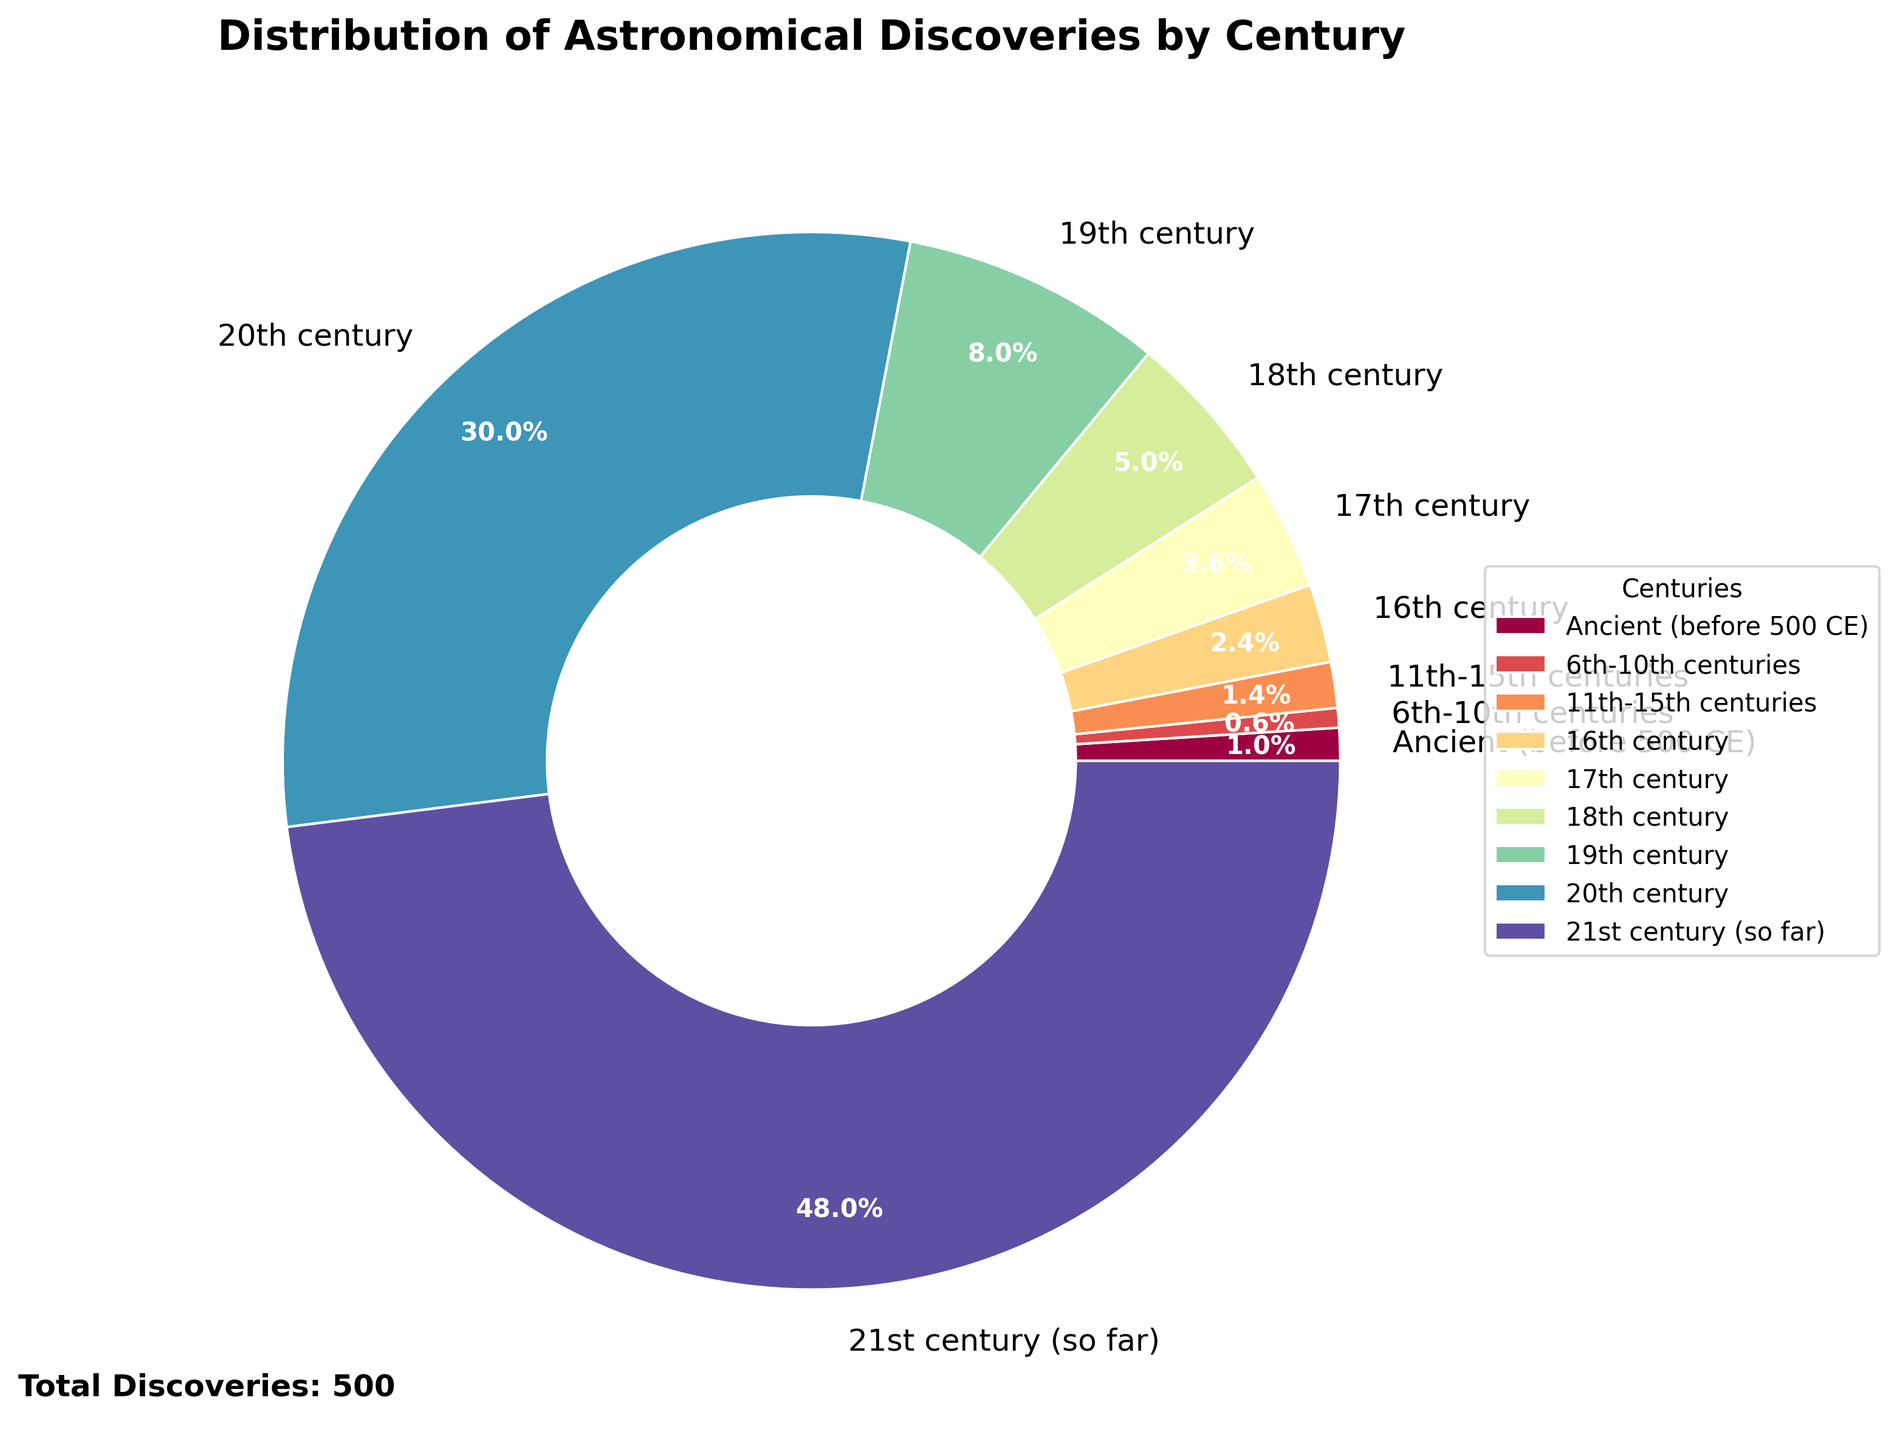What century had the highest percentage of astronomical discoveries? The 21st century (so far) has 240 discoveries. To find the percentage, look at the pie chart, which shows that the 21st century takes up the largest portion of the chart.
Answer: 21st century (so far) What's the difference in the number of discoveries between the 19th and 20th centuries? The number of discoveries in the 19th century is 40, and in the 20th century, it is 150. The difference is 150 - 40.
Answer: 110 Which centuries combined account for more than half of the total discoveries? By examining the pie chart, the 20th (150 discoveries) and 21st centuries (240 discoveries) combined account for 390 discoveries out of a total of 500. The combined percentage is well over half (50%).
Answer: 20th and 21st centuries Among the centuries listed, which one has the smallest percentage of discoveries and what is this percentage? The 6th-10th centuries have the fewest discoveries at 3. The pie chart shows that this is the smallest wedge, likely around 0.6% of total discoveries.
Answer: 6th-10th centuries, 0.6% How many centuries had fewer than 10 discoveries? From the data: Ancient (5), 6th-10th centuries (3), and 11th-15th centuries (7) all had fewer than 10 discoveries. That's 3 centuries.
Answer: 3 centuries What is the combined percentage of discoveries made in the 16th and 17th centuries? The 16th century had 12 discoveries, and the 17th century had 18. Thus, together they made 30 discoveries. 30 out of 500 is (30/500)*100 = 6%.
Answer: 6% Which century shows more discoveries, the 16th or the 11th-15th? The 16th century had 12 discoveries, while the 11th-15th centuries had 7.
Answer: 16th century What is the average number of discoveries per century for the 17th, 18th, and 19th centuries? Sum the discoveries for the 17th (18), 18th (25), and 19th (40) centuries: 18 + 25 + 40 = 83. Divide by 3 to find the average: 83/3 = 27.67.
Answer: 27.67 How does the percentage of discoveries in the 20th century compare to the 18th century? The pie chart indicates that the 20th century (150 discoveries) has a much larger percentage of discoveries than the 18th century (25 discoveries). Utilizing percentages, the 20th century is 30%, whereas the 18th century is 5%.
Answer: 20th century is much larger What trends can be observed in the rate of astronomical discoveries over time? The chart shows a clear increase in discoveries over time, with dramatic growth particularly in the 20th and 21st centuries, indicating accelerated advancements in astronomy.
Answer: Increasing trend 